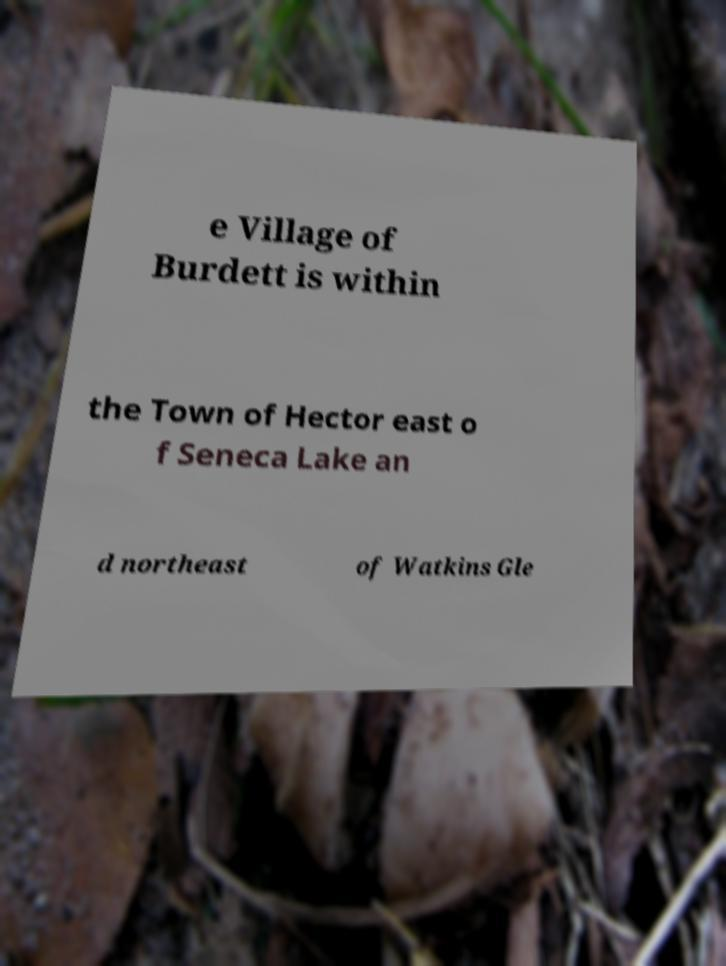Can you read and provide the text displayed in the image?This photo seems to have some interesting text. Can you extract and type it out for me? e Village of Burdett is within the Town of Hector east o f Seneca Lake an d northeast of Watkins Gle 